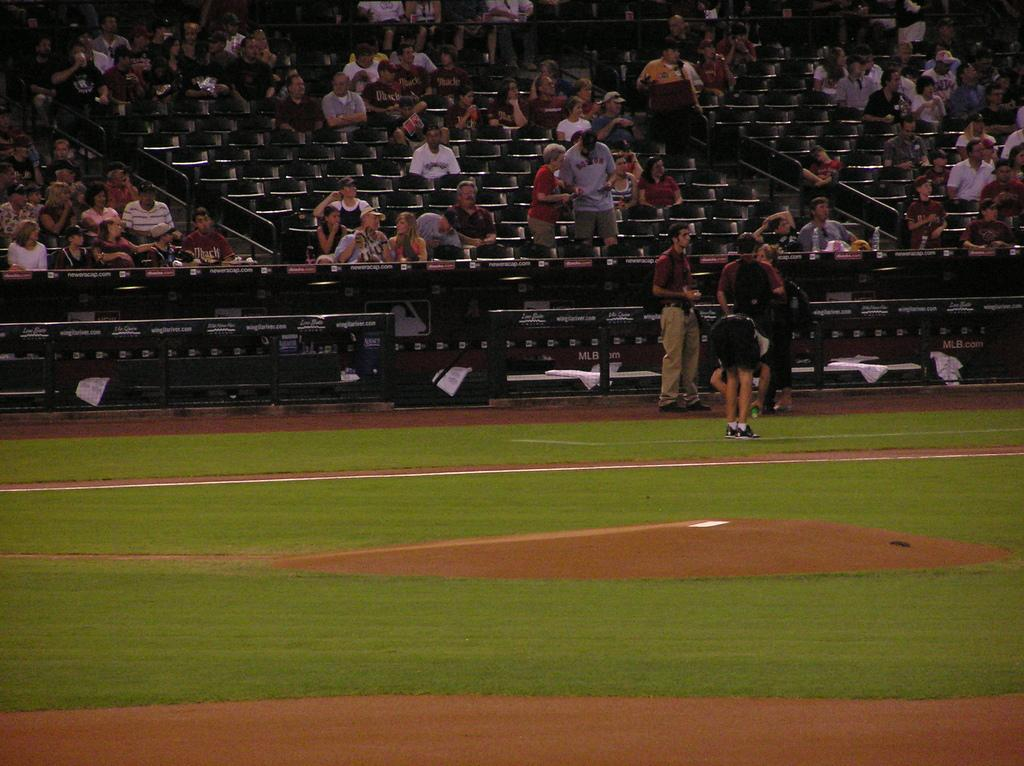How many people are in the image? There are people in the image, but the exact number is not specified. What are some of the people doing in the image? Some people are standing, and some are sitting on chairs. What type of surface is visible in the image? There is grass visible in the image. What type of barrier is present in the image? There is a fence in the image. What type of furniture is present in the image? There are chairs in the image. Can you describe any other objects in the image? There are other unspecified objects in the image. What type of comb is being used to exchange drugs in the image? There is no comb or drug exchange present in the image. 